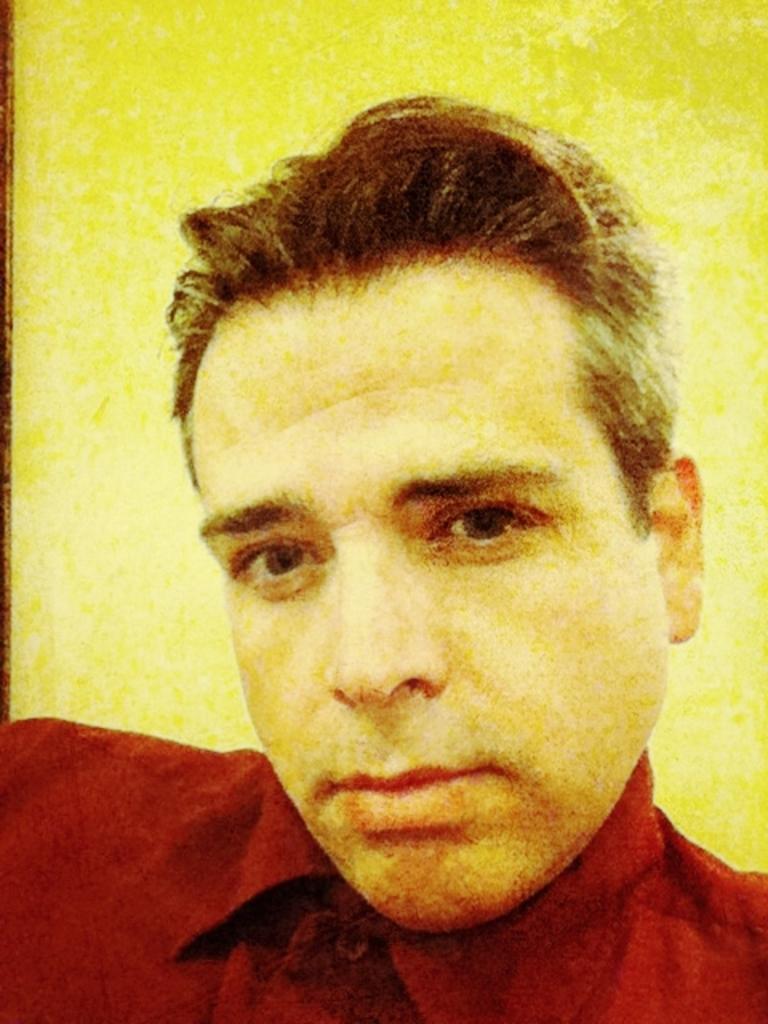In one or two sentences, can you explain what this image depicts? In this image we can see a person's face. In the background there is a wall. 